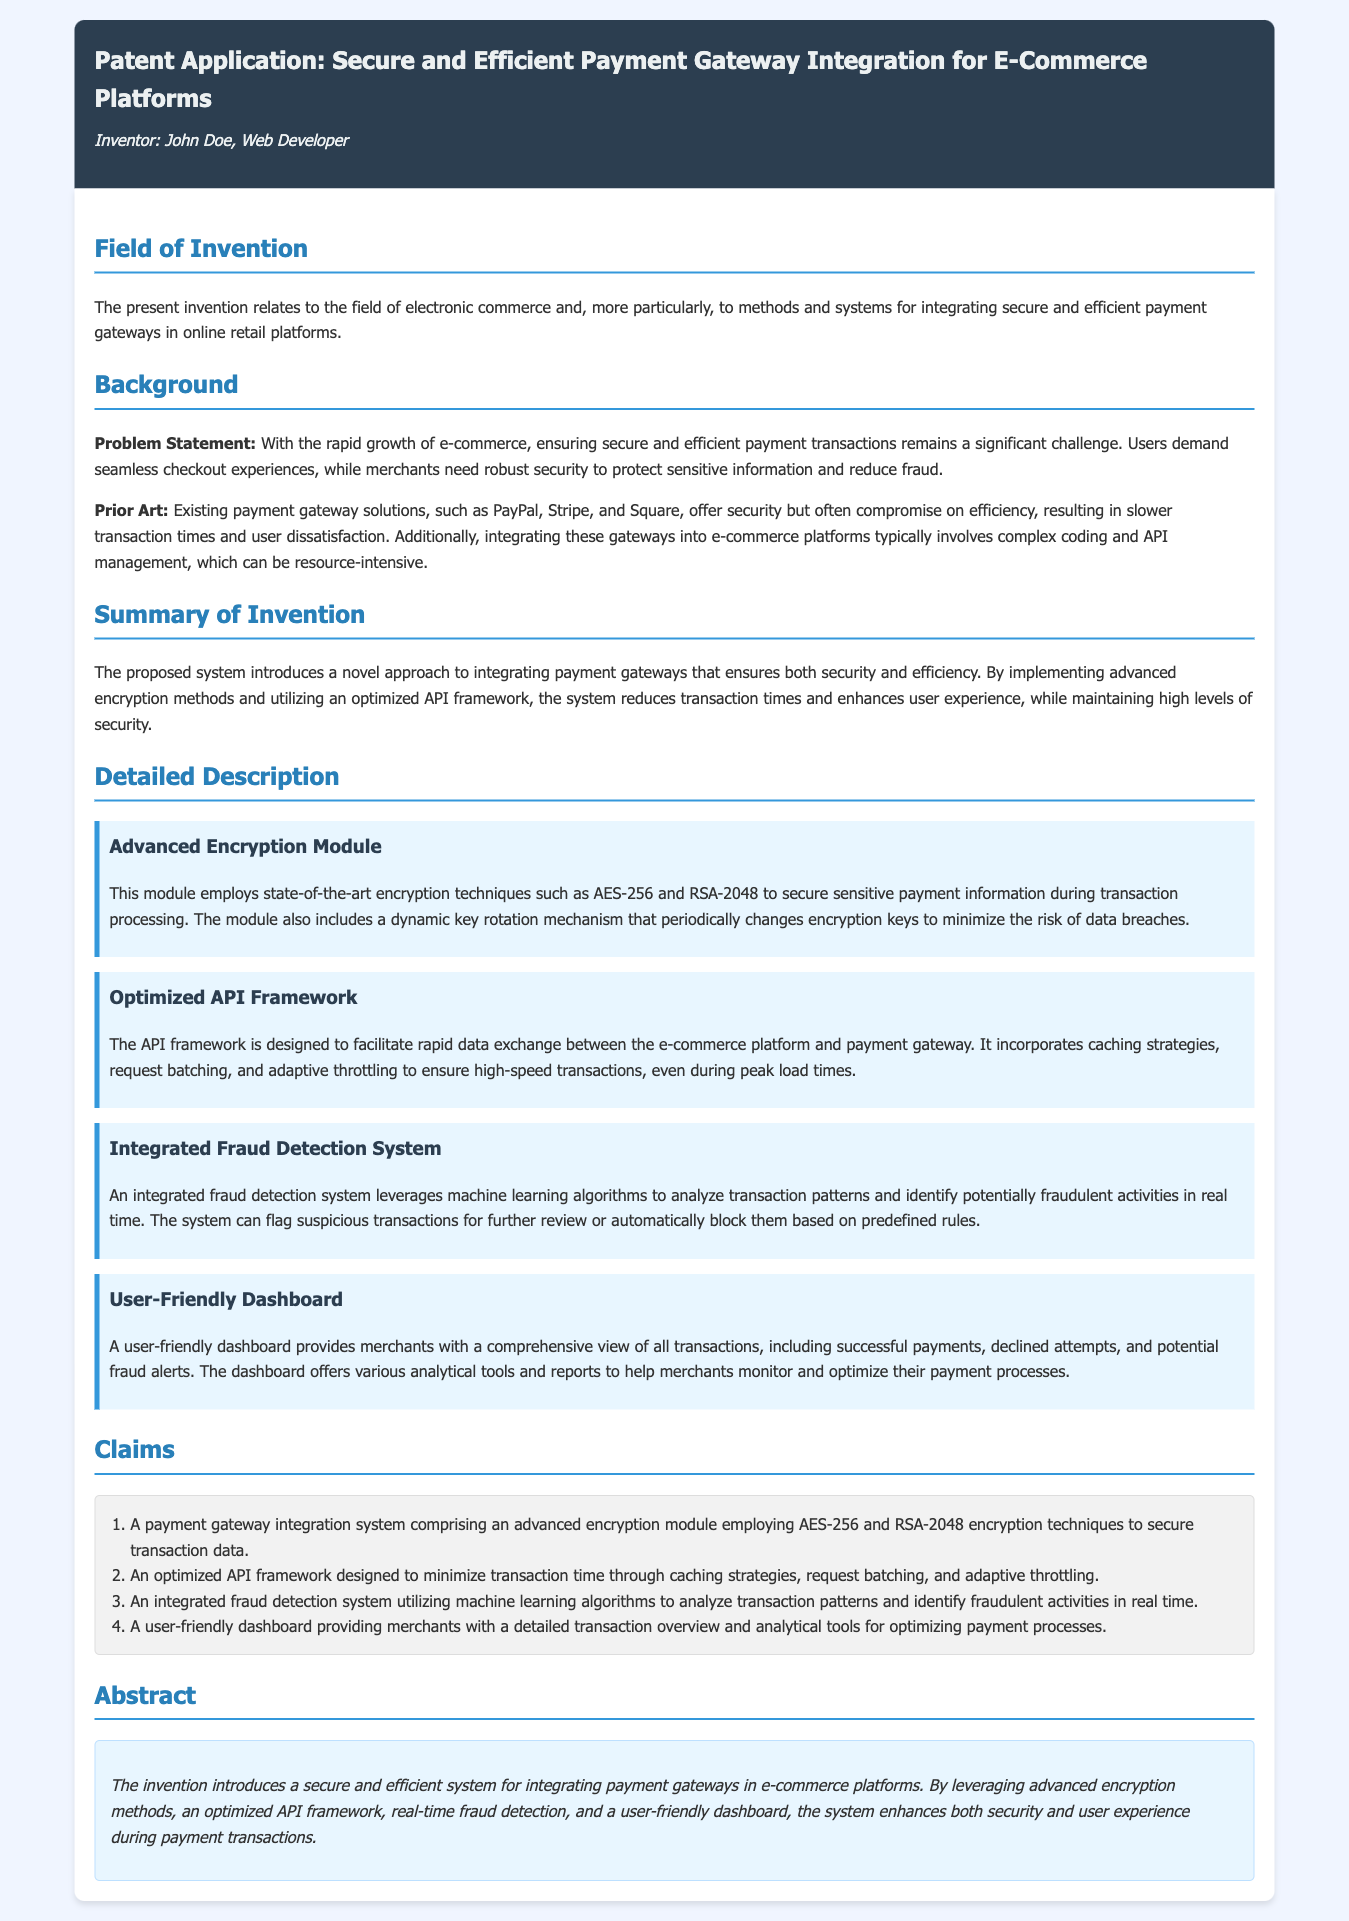What is the title of the patent application? The title is stated in the header of the document, which outlines the focus of the patent application.
Answer: Secure and Efficient Payment Gateway Integration for E-Commerce Platforms Who is the inventor listed in the document? The inventor's name is presented in the header under the title of the patent application.
Answer: John Doe What encryption techniques does the Advanced Encryption Module employ? This information is provided in the detailed description section, specifically under the Advanced Encryption Module component.
Answer: AES-256 and RSA-2048 What type of algorithms does the integrated fraud detection system use? This is detailed in the description of the fraud detection system in the document, explaining how it identifies fraudulent activities.
Answer: Machine learning algorithms What is the primary problem statement addressed in the patent? The problem statement is outlined in the background section, summarizing the challenges faced in the e-commerce payment landscape.
Answer: Ensuring secure and efficient payment transactions How many claims are made in the patent application? The number of claims is specified in the claims section of the document, where each claim is listed.
Answer: Four What is one feature of the user-friendly dashboard? This feature is described in the section dedicated to the user-friendly dashboard, providing insights into its functionalities.
Answer: Comprehensive view of all transactions What is the main advantage of the proposed payment gateway integration system? The summary of the invention highlights the primary advantage of the proposed system, indicating improvements in both security and efficiency.
Answer: Enhances both security and user experience What does the optimized API framework aim to minimize? The optimized API framework's purpose is stated in the detailed description section, focusing on its performance in transaction processing.
Answer: Transaction time 